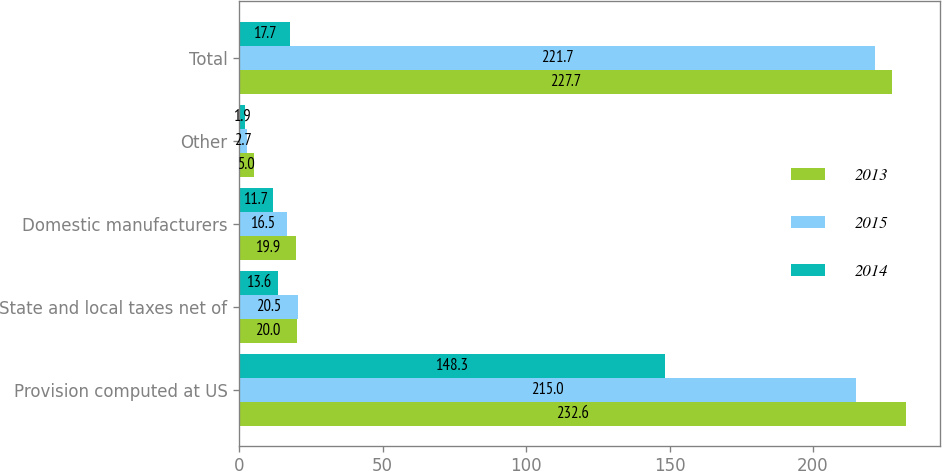Convert chart. <chart><loc_0><loc_0><loc_500><loc_500><stacked_bar_chart><ecel><fcel>Provision computed at US<fcel>State and local taxes net of<fcel>Domestic manufacturers<fcel>Other<fcel>Total<nl><fcel>2013<fcel>232.6<fcel>20<fcel>19.9<fcel>5<fcel>227.7<nl><fcel>2015<fcel>215<fcel>20.5<fcel>16.5<fcel>2.7<fcel>221.7<nl><fcel>2014<fcel>148.3<fcel>13.6<fcel>11.7<fcel>1.9<fcel>17.7<nl></chart> 